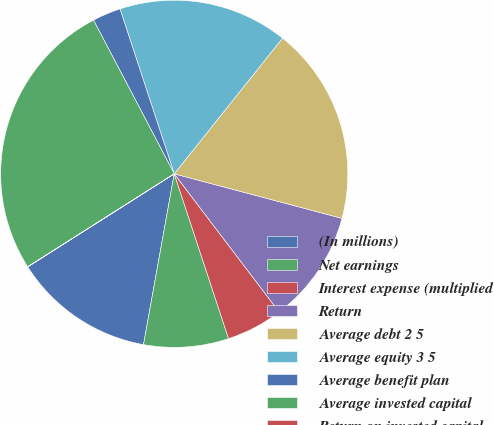<chart> <loc_0><loc_0><loc_500><loc_500><pie_chart><fcel>(In millions)<fcel>Net earnings<fcel>Interest expense (multiplied<fcel>Return<fcel>Average debt 2 5<fcel>Average equity 3 5<fcel>Average benefit plan<fcel>Average invested capital<fcel>Return on invested capital<nl><fcel>13.16%<fcel>7.9%<fcel>5.27%<fcel>10.53%<fcel>18.41%<fcel>15.78%<fcel>2.64%<fcel>26.3%<fcel>0.01%<nl></chart> 